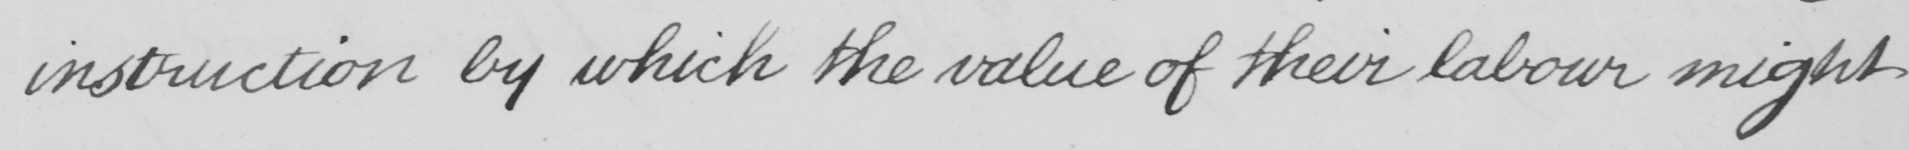Please transcribe the handwritten text in this image. instruction by which the value of their labour might 